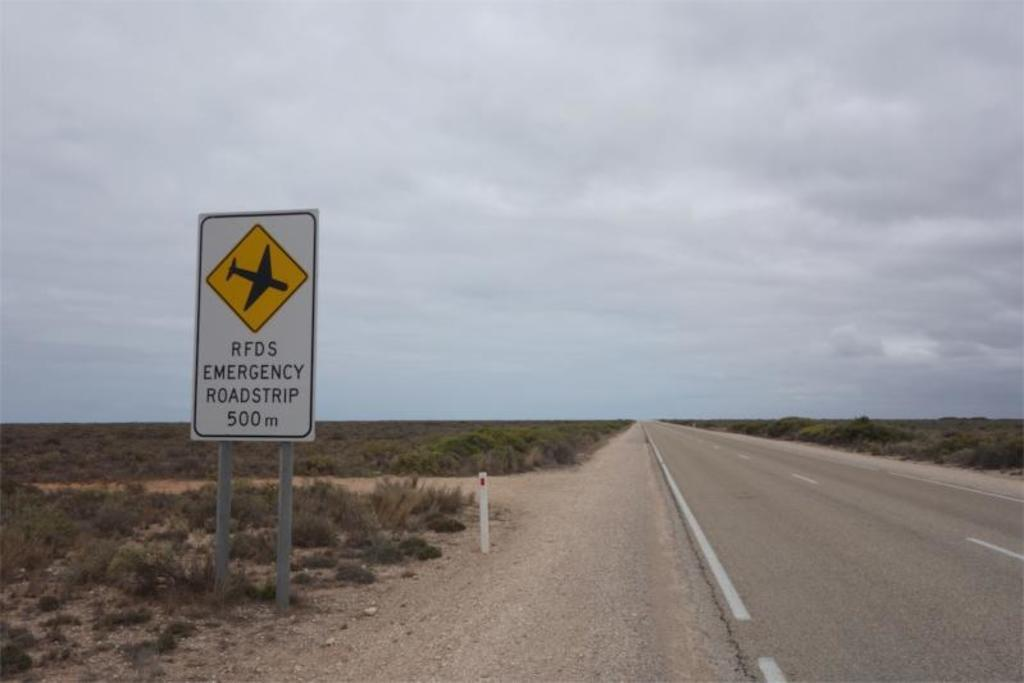Provide a one-sentence caption for the provided image. A sign next to an empty road explaining that it can be used as an Emergency Roadstrip for airplanes. 